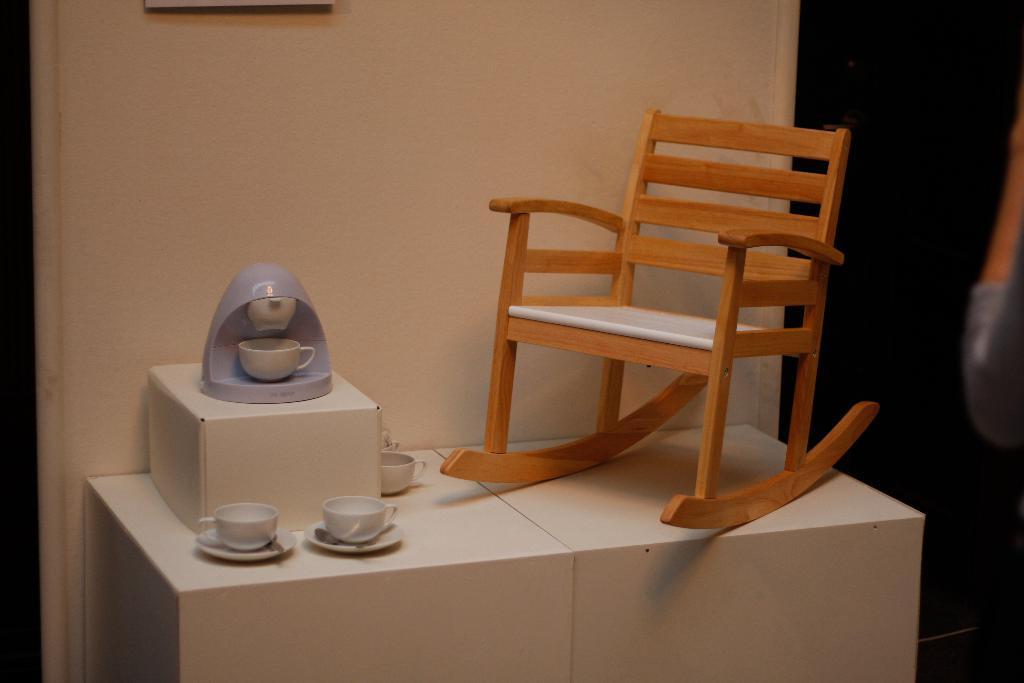Please provide a concise description of this image. This is an empty wooden chair. I can see four cups,two with saucers. This looks like a machine which is purple in color placed on the white box. This is the wall at background. At the right side of the image that looks like a wooden door. 